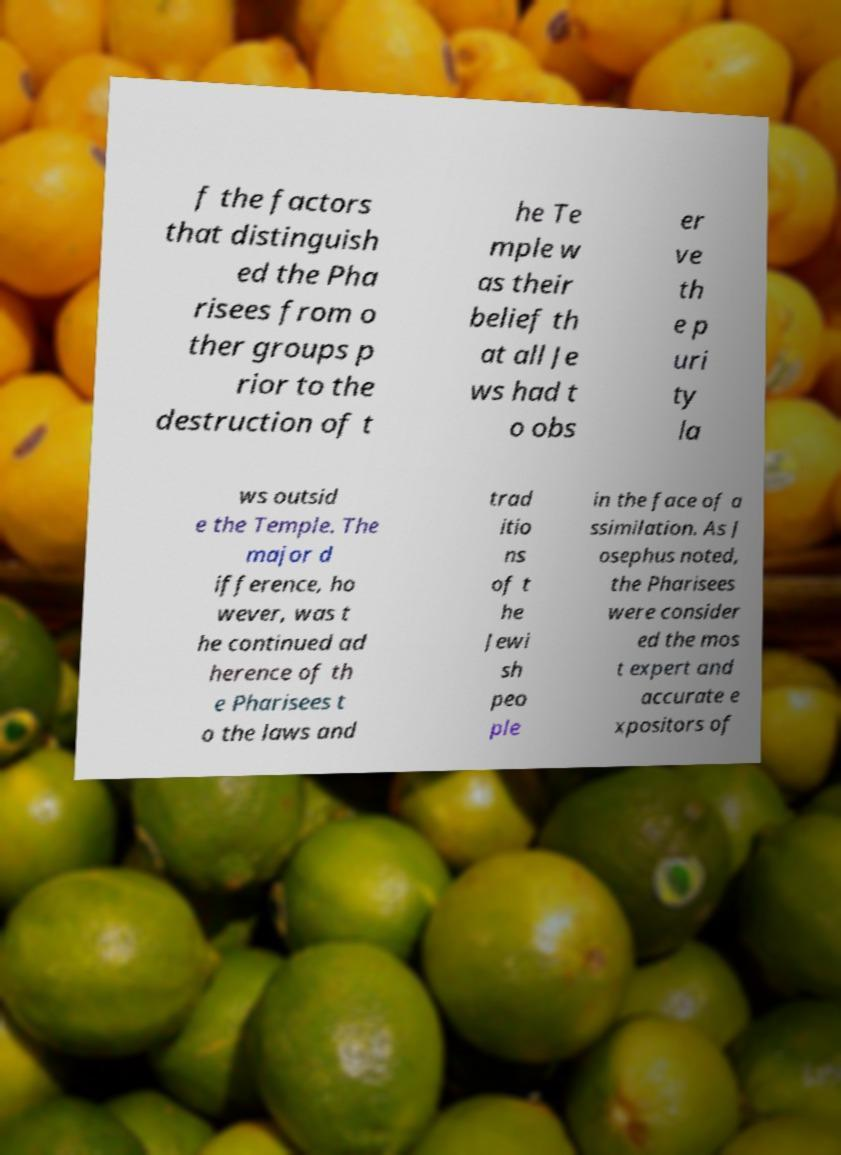For documentation purposes, I need the text within this image transcribed. Could you provide that? f the factors that distinguish ed the Pha risees from o ther groups p rior to the destruction of t he Te mple w as their belief th at all Je ws had t o obs er ve th e p uri ty la ws outsid e the Temple. The major d ifference, ho wever, was t he continued ad herence of th e Pharisees t o the laws and trad itio ns of t he Jewi sh peo ple in the face of a ssimilation. As J osephus noted, the Pharisees were consider ed the mos t expert and accurate e xpositors of 